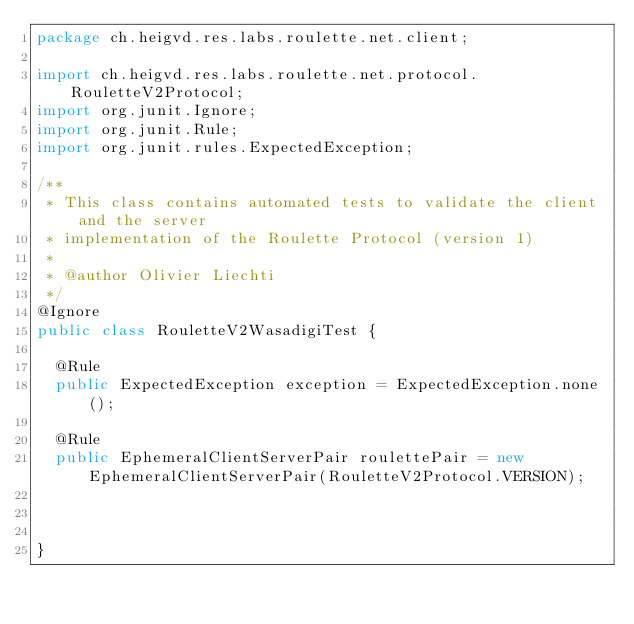<code> <loc_0><loc_0><loc_500><loc_500><_Java_>package ch.heigvd.res.labs.roulette.net.client;

import ch.heigvd.res.labs.roulette.net.protocol.RouletteV2Protocol;
import org.junit.Ignore;
import org.junit.Rule;
import org.junit.rules.ExpectedException;

/**
 * This class contains automated tests to validate the client and the server
 * implementation of the Roulette Protocol (version 1)
 *
 * @author Olivier Liechti
 */
@Ignore
public class RouletteV2WasadigiTest {

  @Rule
  public ExpectedException exception = ExpectedException.none();

  @Rule
  public EphemeralClientServerPair roulettePair = new EphemeralClientServerPair(RouletteV2Protocol.VERSION);


  
}
</code> 